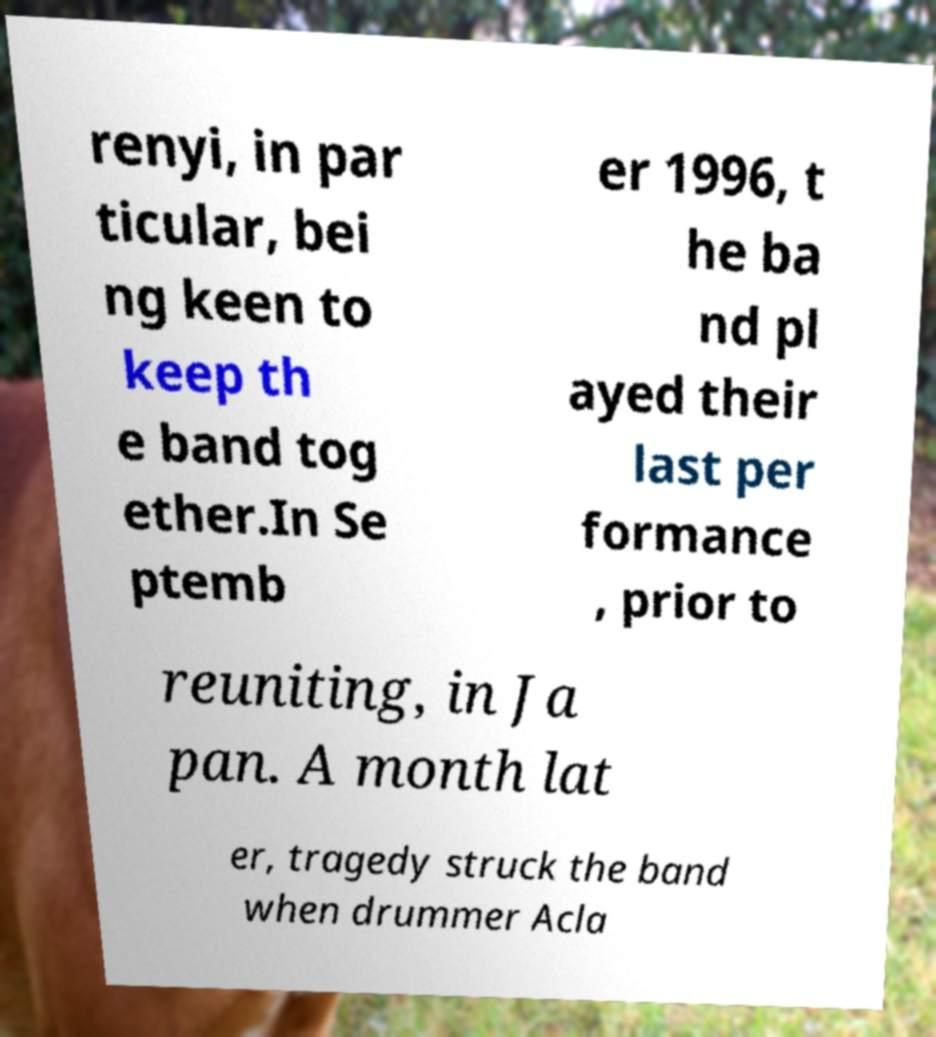Please identify and transcribe the text found in this image. renyi, in par ticular, bei ng keen to keep th e band tog ether.In Se ptemb er 1996, t he ba nd pl ayed their last per formance , prior to reuniting, in Ja pan. A month lat er, tragedy struck the band when drummer Acla 